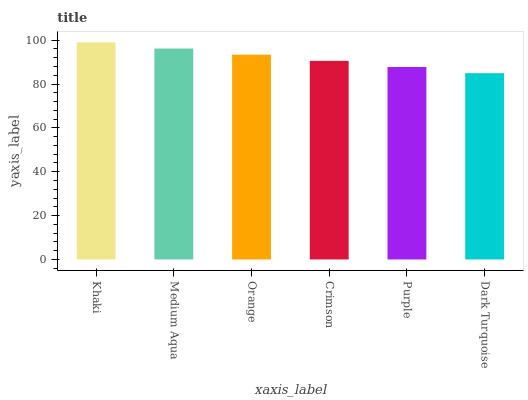Is Medium Aqua the minimum?
Answer yes or no. No. Is Medium Aqua the maximum?
Answer yes or no. No. Is Khaki greater than Medium Aqua?
Answer yes or no. Yes. Is Medium Aqua less than Khaki?
Answer yes or no. Yes. Is Medium Aqua greater than Khaki?
Answer yes or no. No. Is Khaki less than Medium Aqua?
Answer yes or no. No. Is Orange the high median?
Answer yes or no. Yes. Is Crimson the low median?
Answer yes or no. Yes. Is Medium Aqua the high median?
Answer yes or no. No. Is Orange the low median?
Answer yes or no. No. 